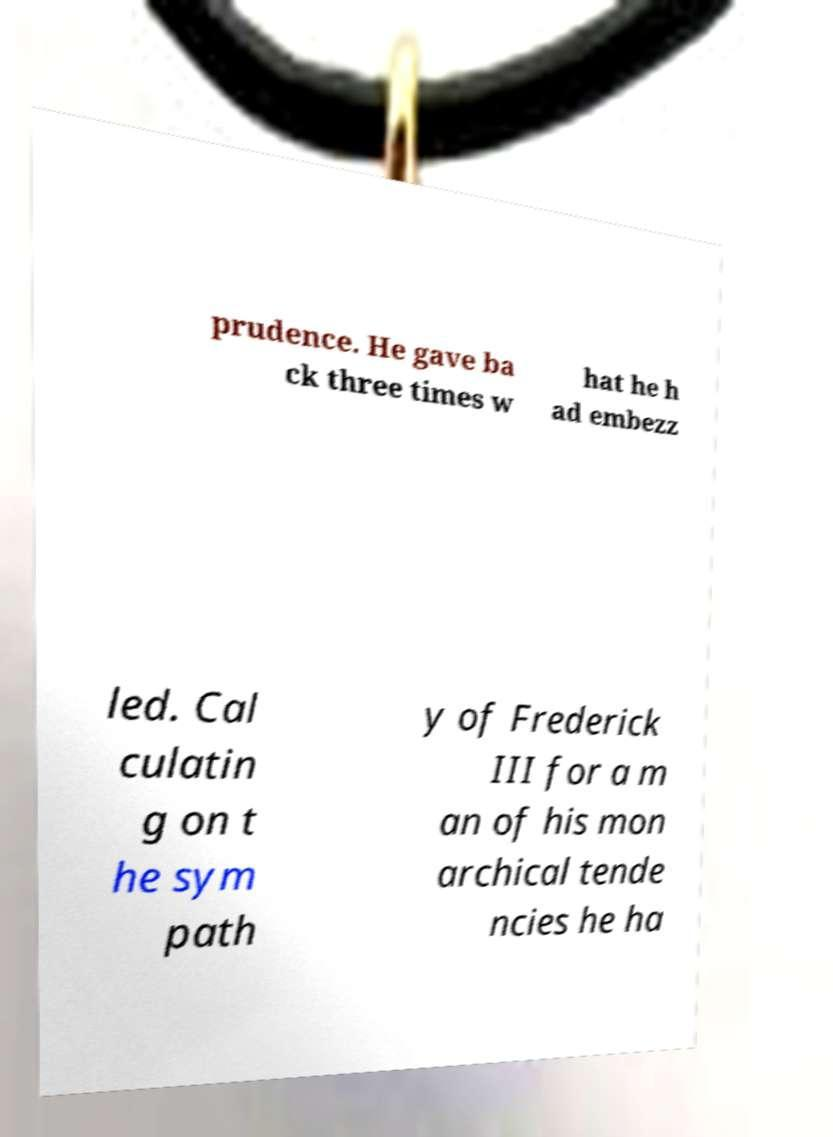Could you assist in decoding the text presented in this image and type it out clearly? prudence. He gave ba ck three times w hat he h ad embezz led. Cal culatin g on t he sym path y of Frederick III for a m an of his mon archical tende ncies he ha 